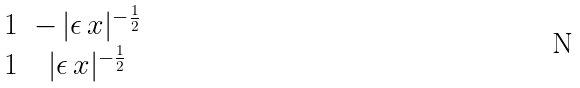<formula> <loc_0><loc_0><loc_500><loc_500>\begin{matrix} 1 & - \, | \epsilon \, x | ^ { - \frac { 1 } { 2 } } \\ 1 & | \epsilon \, x | ^ { - \frac { 1 } { 2 } } \end{matrix}</formula> 